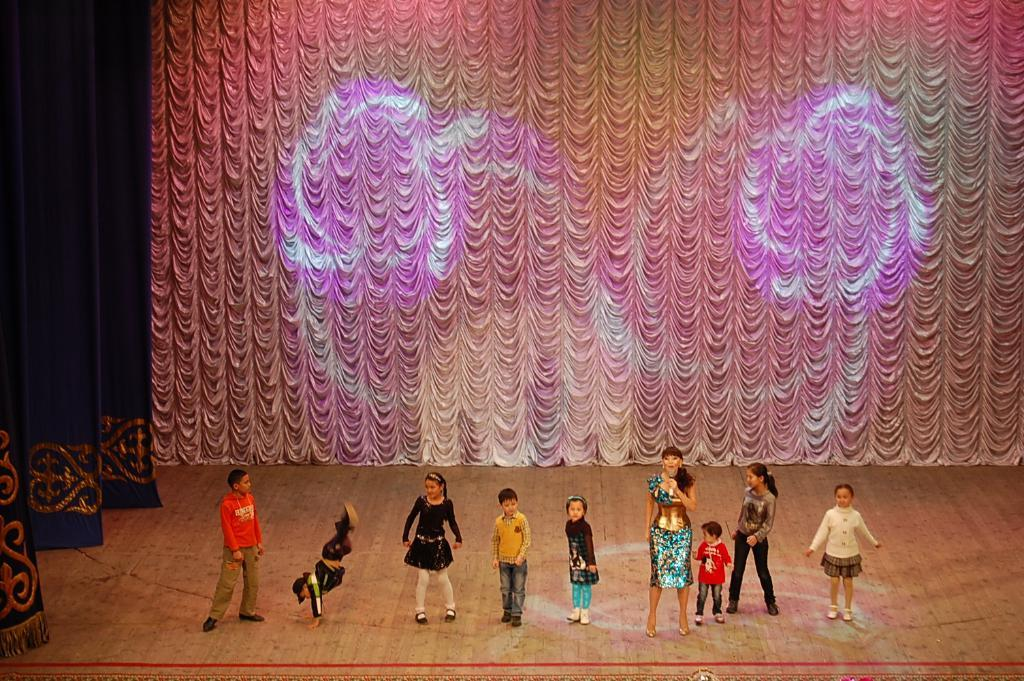Who are the subjects in the image? There are children in the image. What is the lady holding in the image? The lady is holding a mic in the image. Where is the lady located in the image? The lady is on a stage in the image. What can be seen in the background of the image? There is a curtain in the background of the image. What is present on the left side of the image? There are curtains on the left side of the image. What flavor of ice cream do the children prefer in the image? There is no mention of ice cream or any flavor preferences in the image. 